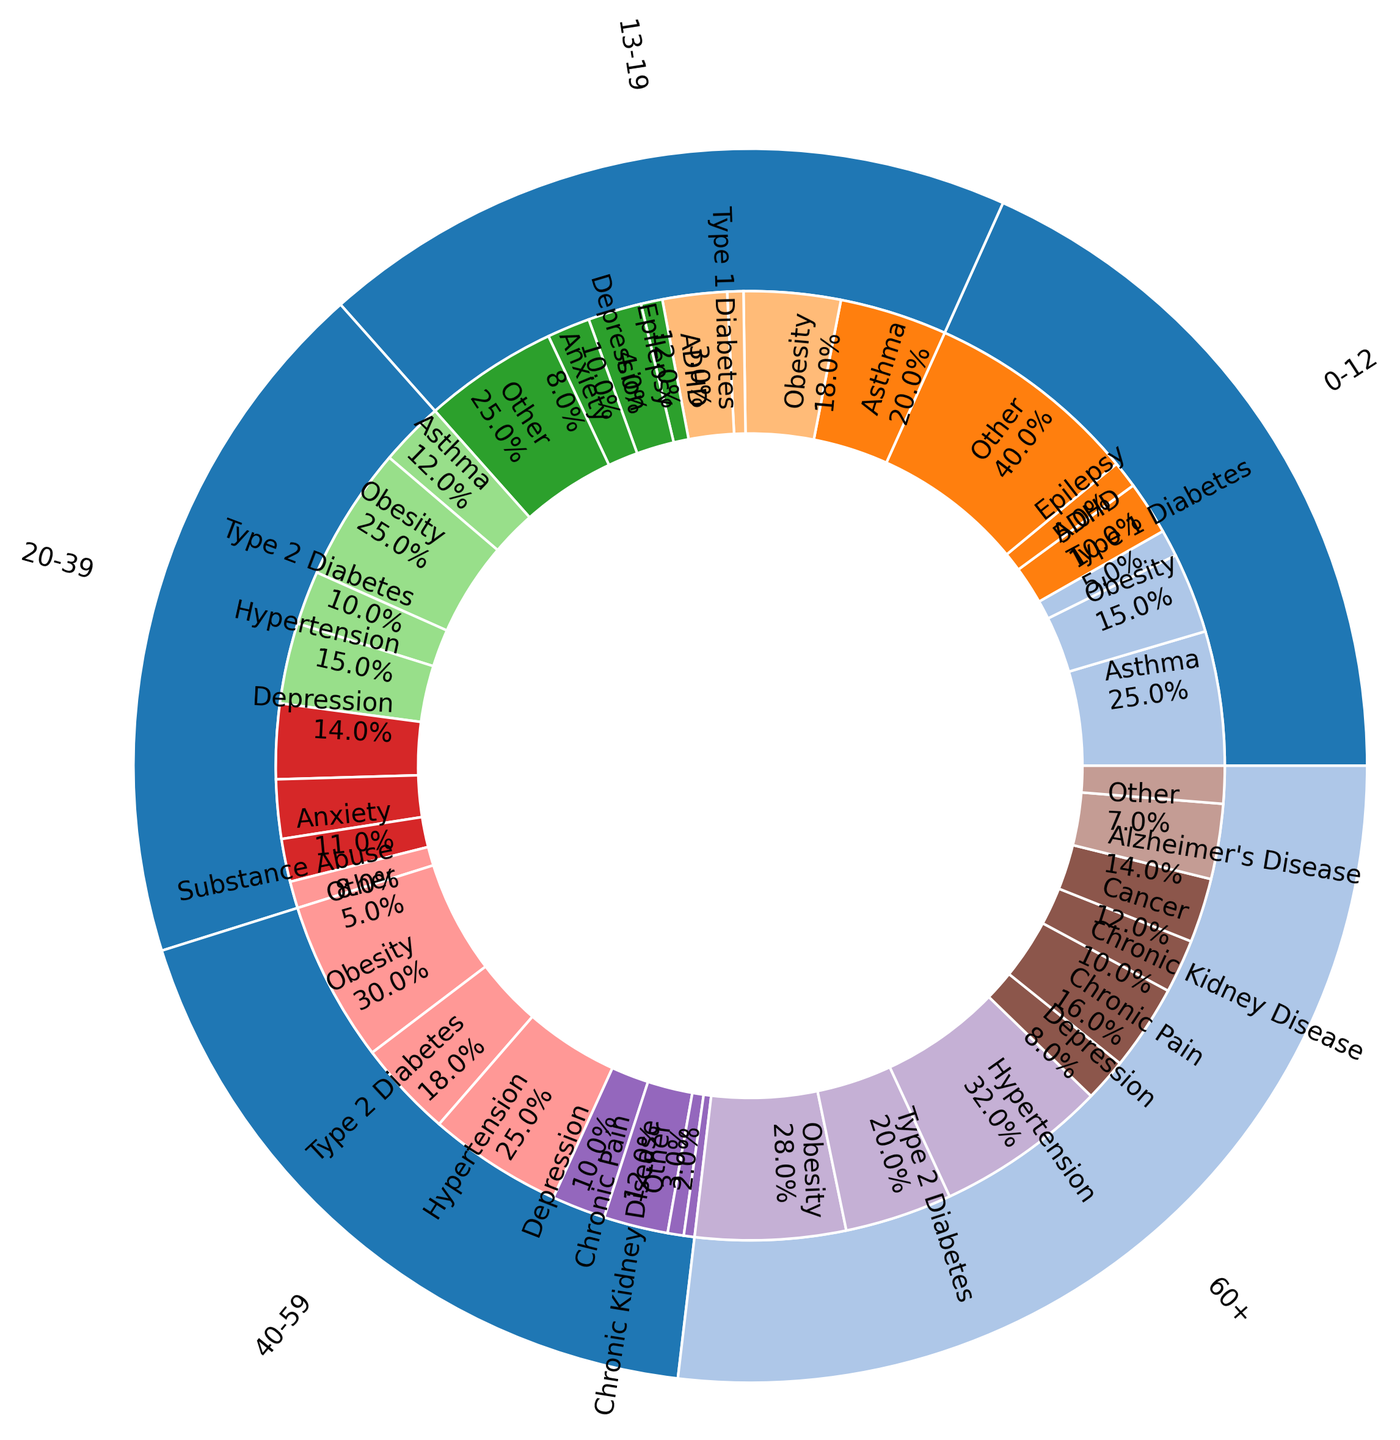Which age group has the highest percentage of individuals with obesity? The innermost ring shows different age groups labeled with corresponding percentages for various comorbidities. In the 40-59 age group, obesity has a percentage of 30%, which is the highest among all age groups for this comorbidity.
Answer: 40-59 In which age group is asthma most prevalent, and what is the respective percentage? The inner ring for age groups and the adjoining sector for comorbidities show that the 0-12 age group has asthma with a prevalence of 25%, identified by the label "Asthma 25%".
Answer: 0-12, 25% What is the total percentage of individuals with depression across all age groups? Depression percentages are given as follows: 13-19 (10%), 20-39 (14%), 40-59 (10%), and 60+ (8%). Summing these up gives 10% + 14% + 10% + 8% = 42%.
Answer: 42% Which comorbidity in the 60+ age group has the second highest percentage, and what is the value? The 60+ age group part of the chart lists the percentages for various comorbidities. Hypertension is the highest at 32%, followed by Type 2 Diabetes at 20%, meaning Type 2 Diabetes is the second highest.
Answer: Type 2 Diabetes, 20% Compare the prevalence of ADHD in the 0-12 and 13-19 age groups. Which age group has a higher percentage, and by how much? The chart shows the 0-12 age group has ADHD at 10% and the 13-19 age group has ADHD at 12%. The 13-19 age group has 2% higher prevalence.
Answer: 13-19, 2% What is the percentage difference in prevalence of Type 2 Diabetes between the 40-59 and 60+ age groups? In the 40-59 age group, Type 2 Diabetes is 18%, while in the 60+ age group, it is 20%. The difference is 20% - 18% = 2%.
Answer: 2% Which comorbidity has the lowest percentage in the 13-19 age group, and what is the percentage? The 13-19 age group section of the chart shows Type 1 Diabetes has the lowest percentage with a value of 3%.
Answer: Type 1 Diabetes, 3% How does the prevalence of obesity compare between the 20-39 and 40-59 age groups? Obesity prevalence is shown in the chart as 25% for the 20-39 age group and 30% for the 40-59 age group. The 40-59 age group has a higher prevalence by 5%.
Answer: The 40-59 age group, by 5% What is the combined percentage of hypertension for the 20-39 and 60+ age groups? The chart lists hypertension as 15% in the 20-39 age group and 32% in the 60+ age group. The combined percentage is 15% + 32% = 47%.
Answer: 47% 